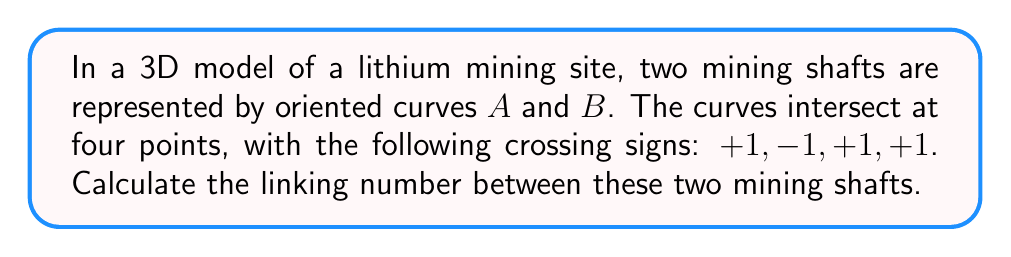Show me your answer to this math problem. To calculate the linking number between two curves in a 3D space, we follow these steps:

1. Identify the crossing points: In this case, we have four intersection points between the two mining shaft curves.

2. Determine the crossing signs: We are given the crossing signs as $+1, -1, +1, +1$.

3. Calculate the linking number using the formula:

   $$Lk(A,B) = \frac{1}{2} \sum_{i} \epsilon_i$$

   Where $Lk(A,B)$ is the linking number between curves $A$ and $B$, and $\epsilon_i$ are the crossing signs.

4. Sum up the crossing signs:
   $$\sum_{i} \epsilon_i = (+1) + (-1) + (+1) + (+1) = +2$$

5. Apply the formula:
   $$Lk(A,B) = \frac{1}{2} \cdot (+2) = +1$$

Therefore, the linking number between the two mining shafts is +1.
Answer: $+1$ 